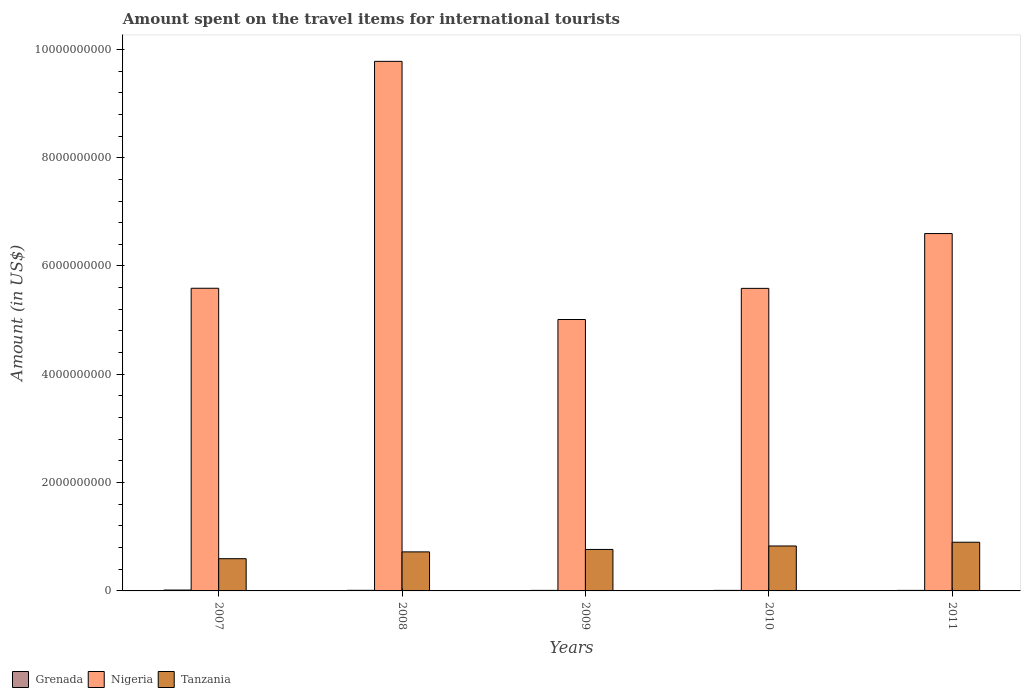Are the number of bars per tick equal to the number of legend labels?
Ensure brevity in your answer.  Yes. How many bars are there on the 2nd tick from the right?
Offer a very short reply. 3. What is the label of the 5th group of bars from the left?
Offer a very short reply. 2011. What is the amount spent on the travel items for international tourists in Nigeria in 2009?
Offer a terse response. 5.01e+09. Across all years, what is the maximum amount spent on the travel items for international tourists in Tanzania?
Your response must be concise. 8.99e+08. Across all years, what is the minimum amount spent on the travel items for international tourists in Tanzania?
Make the answer very short. 5.95e+08. In which year was the amount spent on the travel items for international tourists in Nigeria maximum?
Ensure brevity in your answer.  2008. In which year was the amount spent on the travel items for international tourists in Tanzania minimum?
Give a very brief answer. 2007. What is the total amount spent on the travel items for international tourists in Grenada in the graph?
Your answer should be compact. 5.70e+07. What is the difference between the amount spent on the travel items for international tourists in Tanzania in 2007 and that in 2009?
Your answer should be very brief. -1.71e+08. What is the difference between the amount spent on the travel items for international tourists in Grenada in 2008 and the amount spent on the travel items for international tourists in Tanzania in 2009?
Ensure brevity in your answer.  -7.55e+08. What is the average amount spent on the travel items for international tourists in Grenada per year?
Keep it short and to the point. 1.14e+07. In the year 2007, what is the difference between the amount spent on the travel items for international tourists in Tanzania and amount spent on the travel items for international tourists in Nigeria?
Offer a terse response. -4.99e+09. Is the amount spent on the travel items for international tourists in Tanzania in 2008 less than that in 2009?
Your response must be concise. Yes. Is the difference between the amount spent on the travel items for international tourists in Tanzania in 2008 and 2010 greater than the difference between the amount spent on the travel items for international tourists in Nigeria in 2008 and 2010?
Give a very brief answer. No. What is the difference between the highest and the second highest amount spent on the travel items for international tourists in Nigeria?
Make the answer very short. 3.18e+09. What is the difference between the highest and the lowest amount spent on the travel items for international tourists in Nigeria?
Offer a terse response. 4.77e+09. In how many years, is the amount spent on the travel items for international tourists in Tanzania greater than the average amount spent on the travel items for international tourists in Tanzania taken over all years?
Your response must be concise. 3. What does the 2nd bar from the left in 2007 represents?
Keep it short and to the point. Nigeria. What does the 1st bar from the right in 2009 represents?
Keep it short and to the point. Tanzania. Is it the case that in every year, the sum of the amount spent on the travel items for international tourists in Grenada and amount spent on the travel items for international tourists in Tanzania is greater than the amount spent on the travel items for international tourists in Nigeria?
Your answer should be very brief. No. How many bars are there?
Provide a succinct answer. 15. How many years are there in the graph?
Your answer should be very brief. 5. Are the values on the major ticks of Y-axis written in scientific E-notation?
Give a very brief answer. No. Does the graph contain any zero values?
Provide a short and direct response. No. Does the graph contain grids?
Provide a succinct answer. No. What is the title of the graph?
Your response must be concise. Amount spent on the travel items for international tourists. Does "Sierra Leone" appear as one of the legend labels in the graph?
Your answer should be very brief. No. What is the label or title of the X-axis?
Ensure brevity in your answer.  Years. What is the label or title of the Y-axis?
Provide a short and direct response. Amount (in US$). What is the Amount (in US$) in Grenada in 2007?
Make the answer very short. 1.60e+07. What is the Amount (in US$) in Nigeria in 2007?
Provide a succinct answer. 5.59e+09. What is the Amount (in US$) of Tanzania in 2007?
Your answer should be very brief. 5.95e+08. What is the Amount (in US$) of Grenada in 2008?
Provide a succinct answer. 1.10e+07. What is the Amount (in US$) in Nigeria in 2008?
Ensure brevity in your answer.  9.78e+09. What is the Amount (in US$) in Tanzania in 2008?
Keep it short and to the point. 7.21e+08. What is the Amount (in US$) in Grenada in 2009?
Keep it short and to the point. 1.00e+07. What is the Amount (in US$) of Nigeria in 2009?
Give a very brief answer. 5.01e+09. What is the Amount (in US$) in Tanzania in 2009?
Keep it short and to the point. 7.66e+08. What is the Amount (in US$) of Nigeria in 2010?
Make the answer very short. 5.59e+09. What is the Amount (in US$) of Tanzania in 2010?
Make the answer very short. 8.30e+08. What is the Amount (in US$) in Nigeria in 2011?
Provide a short and direct response. 6.60e+09. What is the Amount (in US$) in Tanzania in 2011?
Your answer should be very brief. 8.99e+08. Across all years, what is the maximum Amount (in US$) of Grenada?
Offer a terse response. 1.60e+07. Across all years, what is the maximum Amount (in US$) of Nigeria?
Offer a terse response. 9.78e+09. Across all years, what is the maximum Amount (in US$) of Tanzania?
Your response must be concise. 8.99e+08. Across all years, what is the minimum Amount (in US$) of Nigeria?
Your answer should be very brief. 5.01e+09. Across all years, what is the minimum Amount (in US$) in Tanzania?
Provide a succinct answer. 5.95e+08. What is the total Amount (in US$) in Grenada in the graph?
Make the answer very short. 5.70e+07. What is the total Amount (in US$) of Nigeria in the graph?
Offer a very short reply. 3.26e+1. What is the total Amount (in US$) of Tanzania in the graph?
Your answer should be compact. 3.81e+09. What is the difference between the Amount (in US$) in Grenada in 2007 and that in 2008?
Offer a very short reply. 5.00e+06. What is the difference between the Amount (in US$) in Nigeria in 2007 and that in 2008?
Provide a succinct answer. -4.19e+09. What is the difference between the Amount (in US$) of Tanzania in 2007 and that in 2008?
Offer a terse response. -1.26e+08. What is the difference between the Amount (in US$) of Nigeria in 2007 and that in 2009?
Your answer should be compact. 5.77e+08. What is the difference between the Amount (in US$) of Tanzania in 2007 and that in 2009?
Offer a very short reply. -1.71e+08. What is the difference between the Amount (in US$) in Tanzania in 2007 and that in 2010?
Make the answer very short. -2.35e+08. What is the difference between the Amount (in US$) of Grenada in 2007 and that in 2011?
Offer a very short reply. 6.00e+06. What is the difference between the Amount (in US$) of Nigeria in 2007 and that in 2011?
Give a very brief answer. -1.01e+09. What is the difference between the Amount (in US$) of Tanzania in 2007 and that in 2011?
Provide a short and direct response. -3.04e+08. What is the difference between the Amount (in US$) in Grenada in 2008 and that in 2009?
Keep it short and to the point. 1.00e+06. What is the difference between the Amount (in US$) in Nigeria in 2008 and that in 2009?
Your response must be concise. 4.77e+09. What is the difference between the Amount (in US$) of Tanzania in 2008 and that in 2009?
Give a very brief answer. -4.50e+07. What is the difference between the Amount (in US$) of Grenada in 2008 and that in 2010?
Your response must be concise. 1.00e+06. What is the difference between the Amount (in US$) of Nigeria in 2008 and that in 2010?
Make the answer very short. 4.19e+09. What is the difference between the Amount (in US$) in Tanzania in 2008 and that in 2010?
Offer a terse response. -1.09e+08. What is the difference between the Amount (in US$) in Grenada in 2008 and that in 2011?
Ensure brevity in your answer.  1.00e+06. What is the difference between the Amount (in US$) in Nigeria in 2008 and that in 2011?
Give a very brief answer. 3.18e+09. What is the difference between the Amount (in US$) in Tanzania in 2008 and that in 2011?
Make the answer very short. -1.78e+08. What is the difference between the Amount (in US$) of Nigeria in 2009 and that in 2010?
Your answer should be compact. -5.75e+08. What is the difference between the Amount (in US$) in Tanzania in 2009 and that in 2010?
Offer a terse response. -6.40e+07. What is the difference between the Amount (in US$) in Grenada in 2009 and that in 2011?
Your answer should be very brief. 0. What is the difference between the Amount (in US$) of Nigeria in 2009 and that in 2011?
Your answer should be compact. -1.59e+09. What is the difference between the Amount (in US$) of Tanzania in 2009 and that in 2011?
Make the answer very short. -1.33e+08. What is the difference between the Amount (in US$) in Grenada in 2010 and that in 2011?
Your answer should be compact. 0. What is the difference between the Amount (in US$) in Nigeria in 2010 and that in 2011?
Your answer should be very brief. -1.01e+09. What is the difference between the Amount (in US$) of Tanzania in 2010 and that in 2011?
Make the answer very short. -6.90e+07. What is the difference between the Amount (in US$) in Grenada in 2007 and the Amount (in US$) in Nigeria in 2008?
Your answer should be compact. -9.76e+09. What is the difference between the Amount (in US$) of Grenada in 2007 and the Amount (in US$) of Tanzania in 2008?
Your answer should be compact. -7.05e+08. What is the difference between the Amount (in US$) in Nigeria in 2007 and the Amount (in US$) in Tanzania in 2008?
Ensure brevity in your answer.  4.87e+09. What is the difference between the Amount (in US$) in Grenada in 2007 and the Amount (in US$) in Nigeria in 2009?
Your answer should be compact. -5.00e+09. What is the difference between the Amount (in US$) in Grenada in 2007 and the Amount (in US$) in Tanzania in 2009?
Your answer should be compact. -7.50e+08. What is the difference between the Amount (in US$) of Nigeria in 2007 and the Amount (in US$) of Tanzania in 2009?
Your answer should be compact. 4.82e+09. What is the difference between the Amount (in US$) in Grenada in 2007 and the Amount (in US$) in Nigeria in 2010?
Make the answer very short. -5.57e+09. What is the difference between the Amount (in US$) in Grenada in 2007 and the Amount (in US$) in Tanzania in 2010?
Your answer should be very brief. -8.14e+08. What is the difference between the Amount (in US$) in Nigeria in 2007 and the Amount (in US$) in Tanzania in 2010?
Make the answer very short. 4.76e+09. What is the difference between the Amount (in US$) of Grenada in 2007 and the Amount (in US$) of Nigeria in 2011?
Give a very brief answer. -6.58e+09. What is the difference between the Amount (in US$) of Grenada in 2007 and the Amount (in US$) of Tanzania in 2011?
Provide a succinct answer. -8.83e+08. What is the difference between the Amount (in US$) in Nigeria in 2007 and the Amount (in US$) in Tanzania in 2011?
Provide a succinct answer. 4.69e+09. What is the difference between the Amount (in US$) of Grenada in 2008 and the Amount (in US$) of Nigeria in 2009?
Offer a very short reply. -5.00e+09. What is the difference between the Amount (in US$) in Grenada in 2008 and the Amount (in US$) in Tanzania in 2009?
Provide a succinct answer. -7.55e+08. What is the difference between the Amount (in US$) of Nigeria in 2008 and the Amount (in US$) of Tanzania in 2009?
Offer a very short reply. 9.01e+09. What is the difference between the Amount (in US$) in Grenada in 2008 and the Amount (in US$) in Nigeria in 2010?
Offer a terse response. -5.58e+09. What is the difference between the Amount (in US$) in Grenada in 2008 and the Amount (in US$) in Tanzania in 2010?
Give a very brief answer. -8.19e+08. What is the difference between the Amount (in US$) in Nigeria in 2008 and the Amount (in US$) in Tanzania in 2010?
Provide a short and direct response. 8.95e+09. What is the difference between the Amount (in US$) of Grenada in 2008 and the Amount (in US$) of Nigeria in 2011?
Offer a terse response. -6.59e+09. What is the difference between the Amount (in US$) in Grenada in 2008 and the Amount (in US$) in Tanzania in 2011?
Keep it short and to the point. -8.88e+08. What is the difference between the Amount (in US$) in Nigeria in 2008 and the Amount (in US$) in Tanzania in 2011?
Your answer should be compact. 8.88e+09. What is the difference between the Amount (in US$) in Grenada in 2009 and the Amount (in US$) in Nigeria in 2010?
Make the answer very short. -5.58e+09. What is the difference between the Amount (in US$) of Grenada in 2009 and the Amount (in US$) of Tanzania in 2010?
Offer a terse response. -8.20e+08. What is the difference between the Amount (in US$) of Nigeria in 2009 and the Amount (in US$) of Tanzania in 2010?
Ensure brevity in your answer.  4.18e+09. What is the difference between the Amount (in US$) of Grenada in 2009 and the Amount (in US$) of Nigeria in 2011?
Provide a short and direct response. -6.59e+09. What is the difference between the Amount (in US$) in Grenada in 2009 and the Amount (in US$) in Tanzania in 2011?
Your answer should be very brief. -8.89e+08. What is the difference between the Amount (in US$) in Nigeria in 2009 and the Amount (in US$) in Tanzania in 2011?
Keep it short and to the point. 4.11e+09. What is the difference between the Amount (in US$) in Grenada in 2010 and the Amount (in US$) in Nigeria in 2011?
Your answer should be compact. -6.59e+09. What is the difference between the Amount (in US$) of Grenada in 2010 and the Amount (in US$) of Tanzania in 2011?
Offer a terse response. -8.89e+08. What is the difference between the Amount (in US$) of Nigeria in 2010 and the Amount (in US$) of Tanzania in 2011?
Make the answer very short. 4.69e+09. What is the average Amount (in US$) of Grenada per year?
Provide a succinct answer. 1.14e+07. What is the average Amount (in US$) of Nigeria per year?
Make the answer very short. 6.51e+09. What is the average Amount (in US$) in Tanzania per year?
Your answer should be very brief. 7.62e+08. In the year 2007, what is the difference between the Amount (in US$) of Grenada and Amount (in US$) of Nigeria?
Provide a short and direct response. -5.57e+09. In the year 2007, what is the difference between the Amount (in US$) of Grenada and Amount (in US$) of Tanzania?
Give a very brief answer. -5.79e+08. In the year 2007, what is the difference between the Amount (in US$) of Nigeria and Amount (in US$) of Tanzania?
Your response must be concise. 4.99e+09. In the year 2008, what is the difference between the Amount (in US$) in Grenada and Amount (in US$) in Nigeria?
Keep it short and to the point. -9.77e+09. In the year 2008, what is the difference between the Amount (in US$) in Grenada and Amount (in US$) in Tanzania?
Offer a very short reply. -7.10e+08. In the year 2008, what is the difference between the Amount (in US$) in Nigeria and Amount (in US$) in Tanzania?
Offer a very short reply. 9.06e+09. In the year 2009, what is the difference between the Amount (in US$) of Grenada and Amount (in US$) of Nigeria?
Make the answer very short. -5.00e+09. In the year 2009, what is the difference between the Amount (in US$) in Grenada and Amount (in US$) in Tanzania?
Provide a succinct answer. -7.56e+08. In the year 2009, what is the difference between the Amount (in US$) in Nigeria and Amount (in US$) in Tanzania?
Your response must be concise. 4.25e+09. In the year 2010, what is the difference between the Amount (in US$) in Grenada and Amount (in US$) in Nigeria?
Make the answer very short. -5.58e+09. In the year 2010, what is the difference between the Amount (in US$) of Grenada and Amount (in US$) of Tanzania?
Ensure brevity in your answer.  -8.20e+08. In the year 2010, what is the difference between the Amount (in US$) in Nigeria and Amount (in US$) in Tanzania?
Your response must be concise. 4.76e+09. In the year 2011, what is the difference between the Amount (in US$) in Grenada and Amount (in US$) in Nigeria?
Ensure brevity in your answer.  -6.59e+09. In the year 2011, what is the difference between the Amount (in US$) of Grenada and Amount (in US$) of Tanzania?
Provide a succinct answer. -8.89e+08. In the year 2011, what is the difference between the Amount (in US$) in Nigeria and Amount (in US$) in Tanzania?
Your response must be concise. 5.70e+09. What is the ratio of the Amount (in US$) in Grenada in 2007 to that in 2008?
Provide a succinct answer. 1.45. What is the ratio of the Amount (in US$) in Nigeria in 2007 to that in 2008?
Keep it short and to the point. 0.57. What is the ratio of the Amount (in US$) of Tanzania in 2007 to that in 2008?
Your response must be concise. 0.83. What is the ratio of the Amount (in US$) of Nigeria in 2007 to that in 2009?
Ensure brevity in your answer.  1.12. What is the ratio of the Amount (in US$) in Tanzania in 2007 to that in 2009?
Offer a terse response. 0.78. What is the ratio of the Amount (in US$) in Tanzania in 2007 to that in 2010?
Offer a very short reply. 0.72. What is the ratio of the Amount (in US$) in Nigeria in 2007 to that in 2011?
Provide a succinct answer. 0.85. What is the ratio of the Amount (in US$) of Tanzania in 2007 to that in 2011?
Provide a short and direct response. 0.66. What is the ratio of the Amount (in US$) in Grenada in 2008 to that in 2009?
Make the answer very short. 1.1. What is the ratio of the Amount (in US$) of Nigeria in 2008 to that in 2009?
Your answer should be very brief. 1.95. What is the ratio of the Amount (in US$) in Tanzania in 2008 to that in 2009?
Offer a terse response. 0.94. What is the ratio of the Amount (in US$) in Grenada in 2008 to that in 2010?
Your answer should be compact. 1.1. What is the ratio of the Amount (in US$) of Nigeria in 2008 to that in 2010?
Your response must be concise. 1.75. What is the ratio of the Amount (in US$) of Tanzania in 2008 to that in 2010?
Your response must be concise. 0.87. What is the ratio of the Amount (in US$) in Grenada in 2008 to that in 2011?
Make the answer very short. 1.1. What is the ratio of the Amount (in US$) of Nigeria in 2008 to that in 2011?
Your answer should be very brief. 1.48. What is the ratio of the Amount (in US$) in Tanzania in 2008 to that in 2011?
Your answer should be compact. 0.8. What is the ratio of the Amount (in US$) in Grenada in 2009 to that in 2010?
Make the answer very short. 1. What is the ratio of the Amount (in US$) of Nigeria in 2009 to that in 2010?
Ensure brevity in your answer.  0.9. What is the ratio of the Amount (in US$) of Tanzania in 2009 to that in 2010?
Provide a short and direct response. 0.92. What is the ratio of the Amount (in US$) in Grenada in 2009 to that in 2011?
Your response must be concise. 1. What is the ratio of the Amount (in US$) of Nigeria in 2009 to that in 2011?
Offer a terse response. 0.76. What is the ratio of the Amount (in US$) in Tanzania in 2009 to that in 2011?
Keep it short and to the point. 0.85. What is the ratio of the Amount (in US$) in Grenada in 2010 to that in 2011?
Give a very brief answer. 1. What is the ratio of the Amount (in US$) in Nigeria in 2010 to that in 2011?
Make the answer very short. 0.85. What is the ratio of the Amount (in US$) of Tanzania in 2010 to that in 2011?
Ensure brevity in your answer.  0.92. What is the difference between the highest and the second highest Amount (in US$) of Grenada?
Offer a terse response. 5.00e+06. What is the difference between the highest and the second highest Amount (in US$) in Nigeria?
Make the answer very short. 3.18e+09. What is the difference between the highest and the second highest Amount (in US$) of Tanzania?
Your answer should be very brief. 6.90e+07. What is the difference between the highest and the lowest Amount (in US$) in Grenada?
Give a very brief answer. 6.00e+06. What is the difference between the highest and the lowest Amount (in US$) in Nigeria?
Offer a terse response. 4.77e+09. What is the difference between the highest and the lowest Amount (in US$) in Tanzania?
Your answer should be compact. 3.04e+08. 